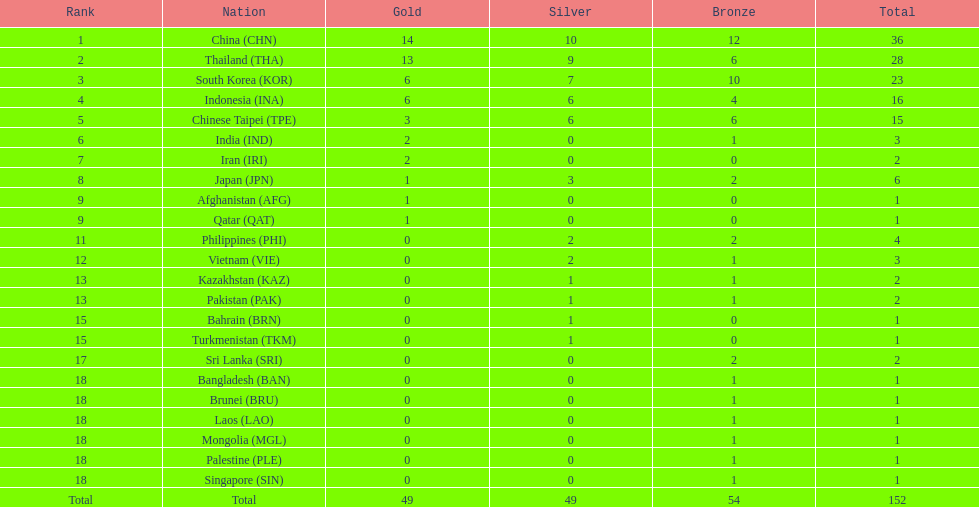How many combined silver medals did china, india, and japan earn ? 13. 